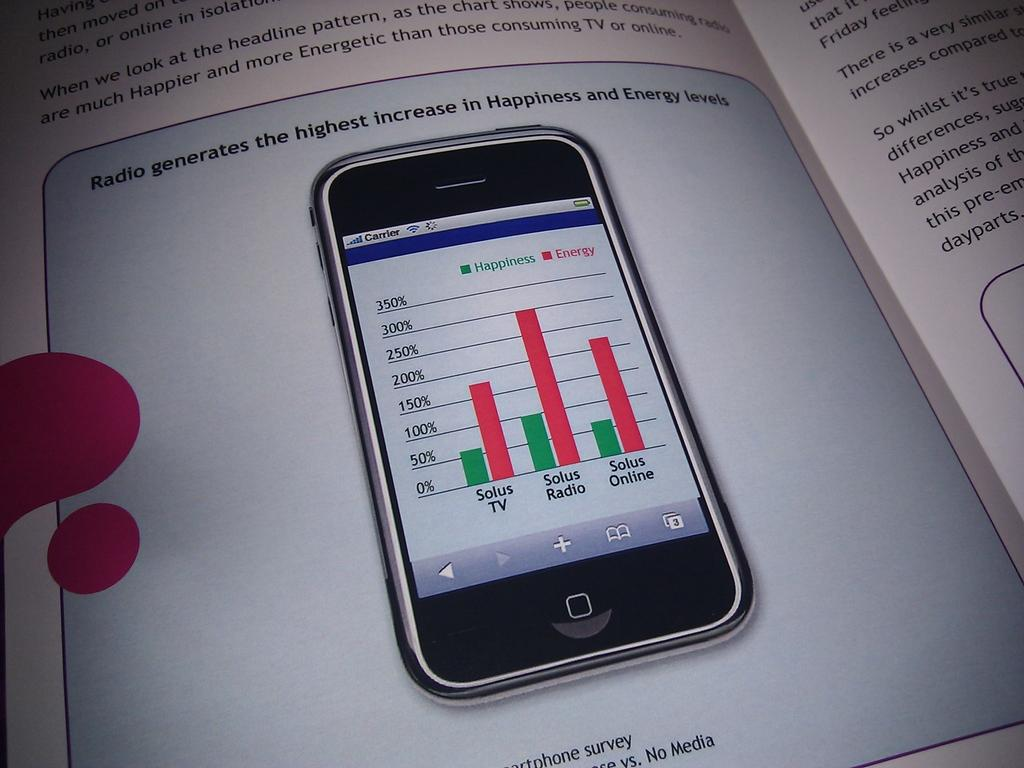<image>
Give a short and clear explanation of the subsequent image. A textbook opened to a page with a cellphone research study that the radio generates the highest increase in happiness and energy levels. 